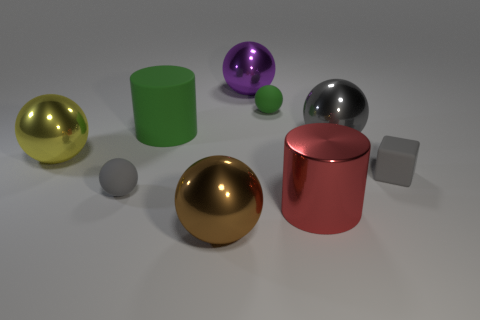What number of objects are blocks or big metal spheres in front of the large yellow shiny sphere? Including the central large yellow shiny sphere, there appears to be one big metal sphere and one block located in front of it, making a total of two objects that fit the description. 